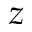<formula> <loc_0><loc_0><loc_500><loc_500>z</formula> 